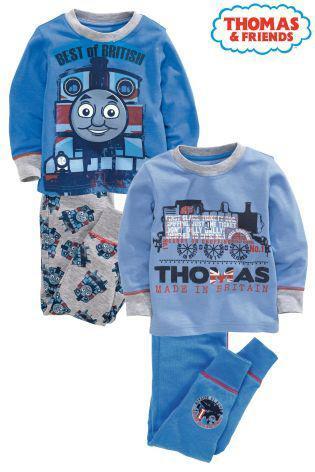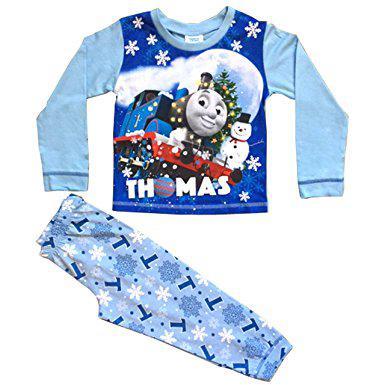The first image is the image on the left, the second image is the image on the right. For the images displayed, is the sentence "There are two sets of pajamas in each of the images." factually correct? Answer yes or no. No. The first image is the image on the left, the second image is the image on the right. Assess this claim about the two images: "No individual image contains more than two sets of sleepwear, and the right image includes a pajama top depicting a cartoon train face.". Correct or not? Answer yes or no. Yes. 